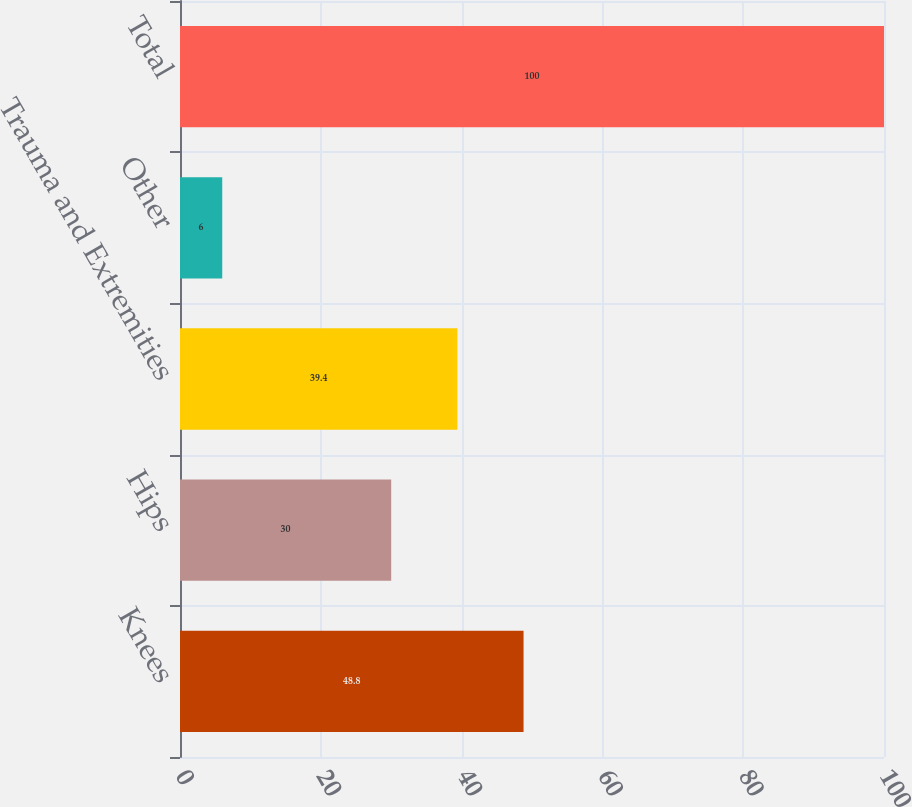Convert chart. <chart><loc_0><loc_0><loc_500><loc_500><bar_chart><fcel>Knees<fcel>Hips<fcel>Trauma and Extremities<fcel>Other<fcel>Total<nl><fcel>48.8<fcel>30<fcel>39.4<fcel>6<fcel>100<nl></chart> 